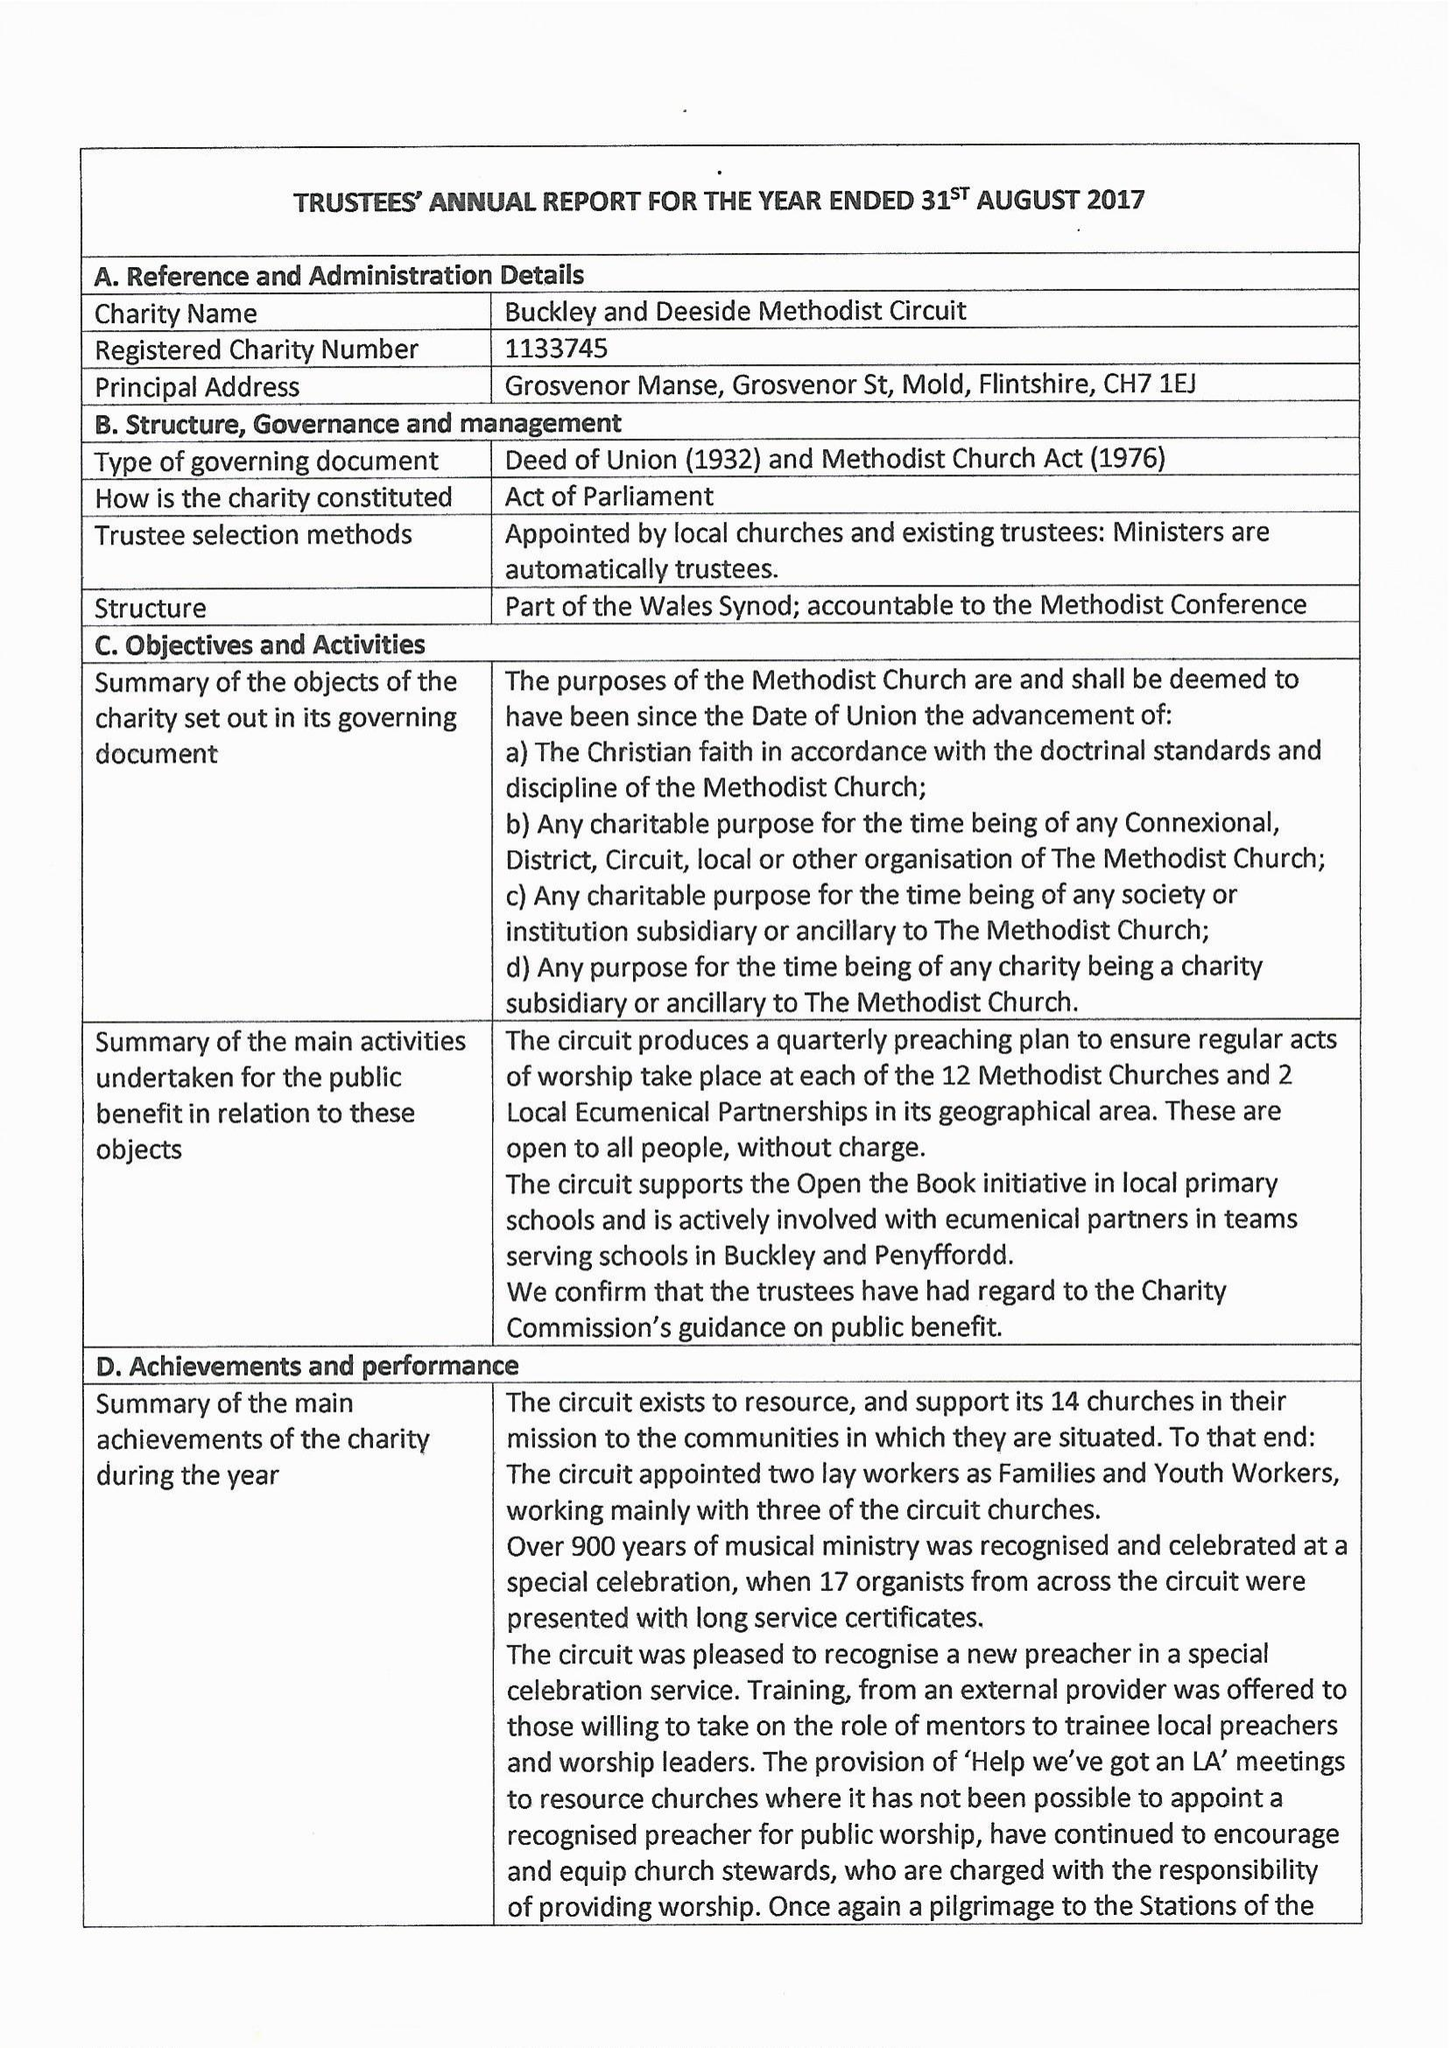What is the value for the income_annually_in_british_pounds?
Answer the question using a single word or phrase. 194591.00 